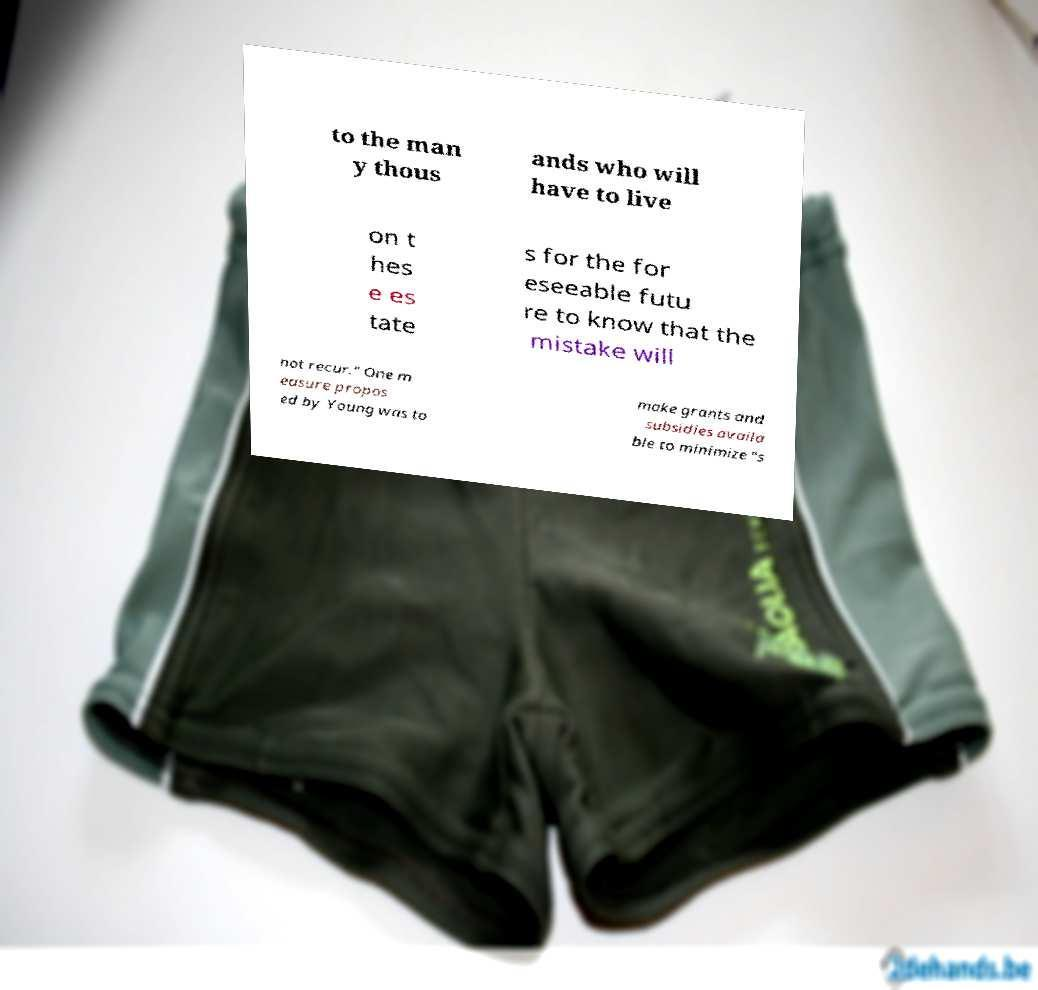For documentation purposes, I need the text within this image transcribed. Could you provide that? to the man y thous ands who will have to live on t hes e es tate s for the for eseeable futu re to know that the mistake will not recur." One m easure propos ed by Young was to make grants and subsidies availa ble to minimize "s 